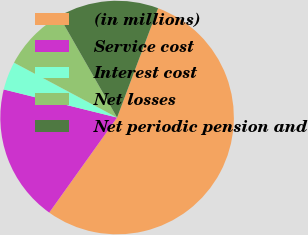Convert chart to OTSL. <chart><loc_0><loc_0><loc_500><loc_500><pie_chart><fcel>(in millions)<fcel>Service cost<fcel>Interest cost<fcel>Net losses<fcel>Net periodic pension and<nl><fcel>54.16%<fcel>19.0%<fcel>3.92%<fcel>8.95%<fcel>13.97%<nl></chart> 